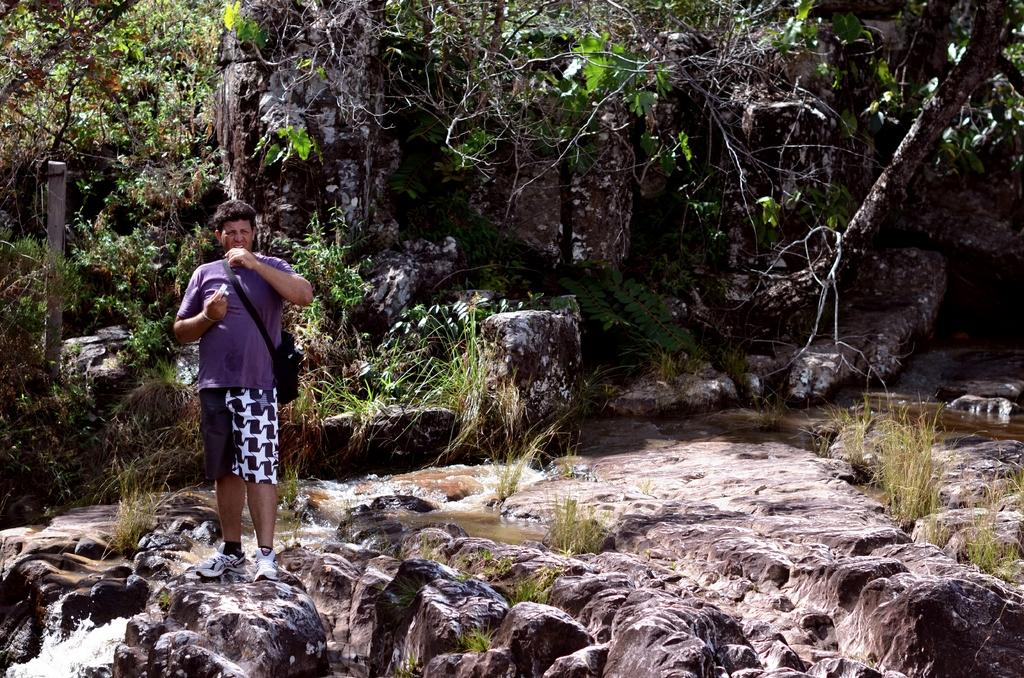What is the main subject of the image? There is a person in the image. What is the person wearing? The person is wearing a bag. What is the person holding? The person is holding an object. What is the person's posture in the image? The person is standing. What type of natural environment is visible in the image? There is water, grass, rocks, and trees visible in the image. What is located on the left side of the image? There is a pole on the left side of the image. Can you tell me how many yaks are grazing in the grass in the image? There are no yaks present in the image; it features a person, a pole, and a natural environment. What type of bird is perched on the pole in the image? There is no bird, specifically an owl, present on the pole in the image. 